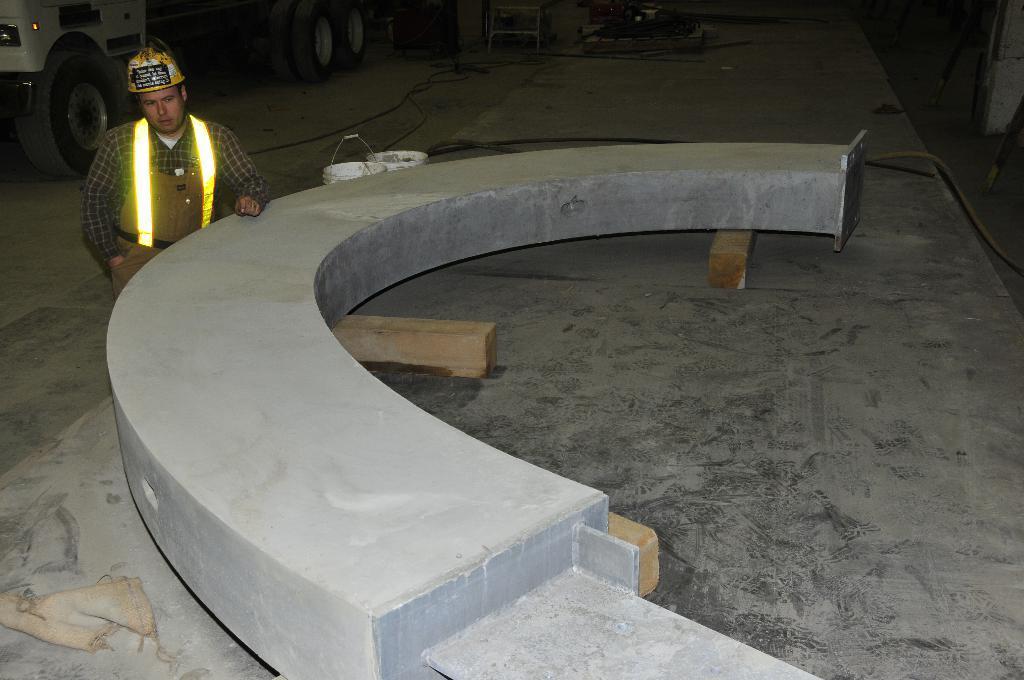Describe this image in one or two sentences. In this picture I can see the arch construction. I can see a person wearing a helmet and standing on the left side. I can see the vehicle. I can see buckets. 